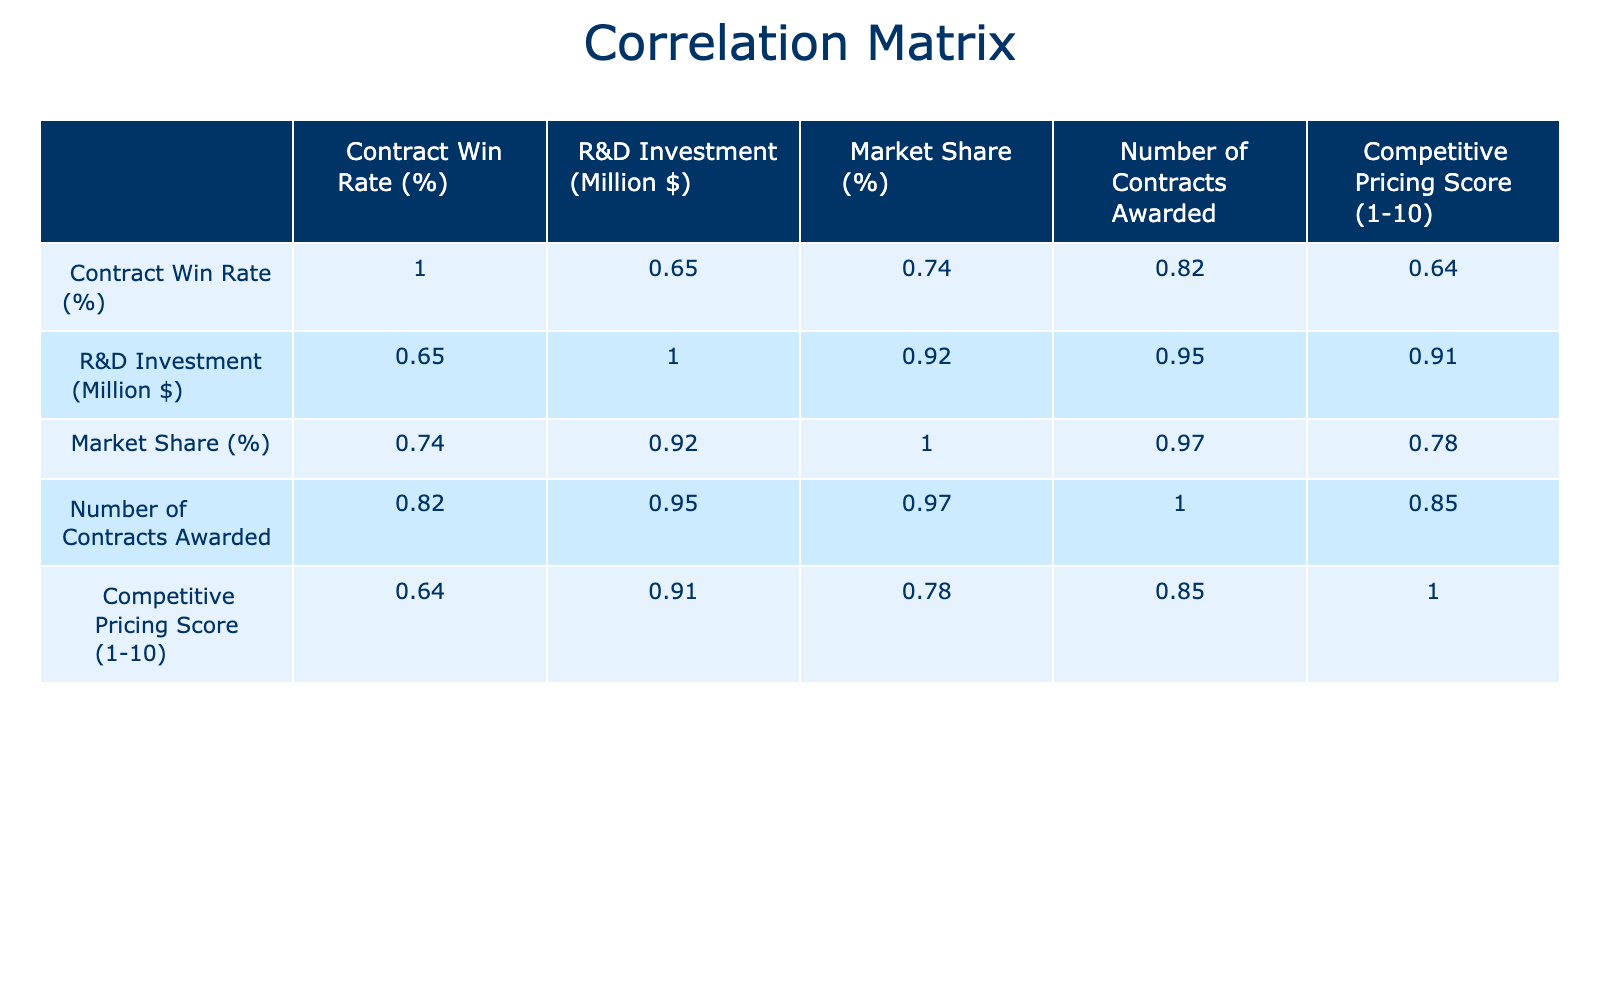What is the highest contract win rate among these companies? The contract win rates are: Lockheed Martin (25), Northrop Grumman (30), Raytheon Technologies (28), Boeing Defense (22), General Dynamics (27), BAE Systems (20), Thales Group (24), Leonardo S.p.A (18), Huntington Ingalls Industries (21), L3Harris Technologies (19). The highest value is 30, from Northrop Grumman.
Answer: 30 Which company has the lowest market share? The market shares are as follows: Lockheed Martin (15), Northrop Grumman (12), Raytheon Technologies (10), Boeing Defense (8), General Dynamics (9), BAE Systems (7), Thales Group (6), Leonardo S.p.A (5), Huntington Ingalls Industries (4), L3Harris Technologies (3). The lowest value, 3, belongs to L3Harris Technologies.
Answer: 3 Is there a positive correlation between R&D investment and contract win rate? To determine correlation, we look at the correlation coefficient for R&D Investment and Contract Win Rate in the table. If the value is positive (greater than 0), it indicates a positive correlation. Since the correlation matrix will show a coefficient here, we can see that R&D Investment and Contract Win Rate correlate positively with a value above 0.
Answer: Yes What is the average competitive pricing score of companies with a contract win rate higher than 25%? The companies with a contract win rate greater than 25% are Northrop Grumman (7), Raytheon Technologies (6), General Dynamics (6), and Lockheed Martin (8). Adding these scores gives: 7 + 6 + 6 + 8 = 27. There are 4 companies, so the average is 27/4 = 6.75.
Answer: 6.75 Which company has the highest R&D investment and what is the corresponding contract win rate? The R&D investments are: Lockheed Martin (1500), Northrop Grumman (1200), Raytheon Technologies (900), Boeing Defense (800), General Dynamics (950), BAE Systems (700), Thales Group (600), Leonardo S.p.A (500), Huntington Ingalls Industries (550), L3Harris Technologies (750). Lockheed Martin has the highest R&D investment at 1500 million, with a contract win rate of 25%.
Answer: Lockheed Martin, 25% Do companies with a higher number of contracts generally have a higher contract win rate? We need to analyze the correlation between Number of Contracts Awarded and Contract Win Rate. By evaluating these two columns in the correlation table, if the correlation coefficient is greater than 0, it means companies with more contracts awarded tend to have higher win rates, indicating a positive relationship. The correlation coefficient will guide this assessment.
Answer: It requires analysis of correlation value What is the difference in market share between the company with the highest and lowest market share? The company with the highest market share is Lockheed Martin (15), and the lowest is L3Harris Technologies (3). Calculating the difference gives: 15 - 3 = 12.
Answer: 12 Which company scored below average in competitive pricing score? The average competitive pricing score of all companies can be found by adding all scores: (8 + 7 + 6 + 5 + 6 + 4 + 5 + 4 + 3 + 6) = 60, then divide by 10, equals 6. Thus, the companies with scores below 6 are BAE Systems (4), Thales Group (5), and Huntington Ingalls Industries (3).
Answer: BAE Systems, Thales Group, Huntington Ingalls Industries 